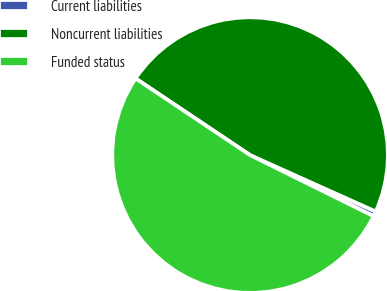Convert chart. <chart><loc_0><loc_0><loc_500><loc_500><pie_chart><fcel>Current liabilities<fcel>Noncurrent liabilities<fcel>Funded status<nl><fcel>0.6%<fcel>47.33%<fcel>52.07%<nl></chart> 